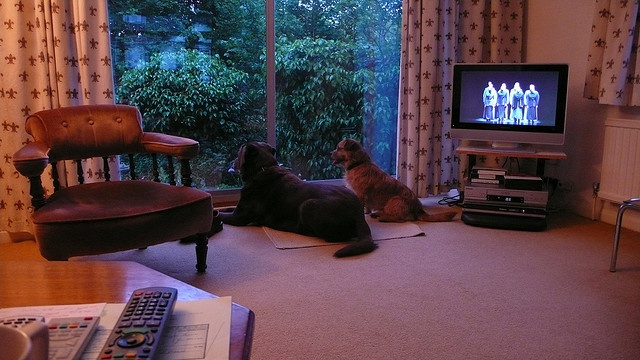Describe the objects in this image and their specific colors. I can see chair in salmon, black, maroon, and brown tones, dog in salmon, black, navy, and purple tones, tv in salmon, black, navy, maroon, and purple tones, dining table in salmon, brown, and violet tones, and dog in salmon, black, maroon, and purple tones in this image. 